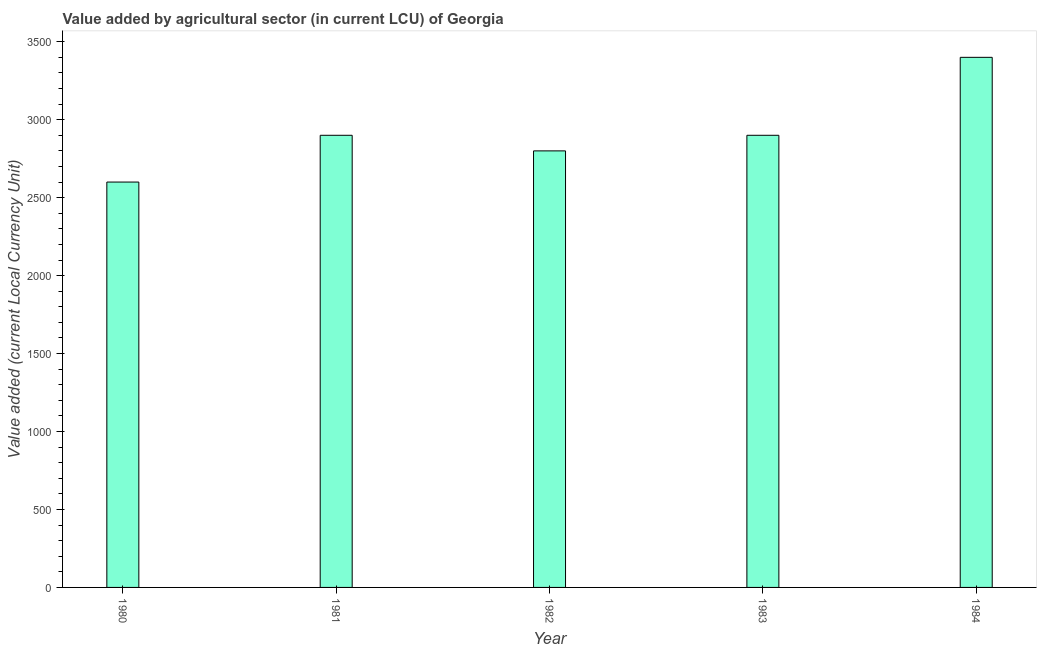What is the title of the graph?
Provide a short and direct response. Value added by agricultural sector (in current LCU) of Georgia. What is the label or title of the Y-axis?
Your answer should be compact. Value added (current Local Currency Unit). What is the value added by agriculture sector in 1981?
Keep it short and to the point. 2900. Across all years, what is the maximum value added by agriculture sector?
Your answer should be very brief. 3400. Across all years, what is the minimum value added by agriculture sector?
Your answer should be compact. 2600. What is the sum of the value added by agriculture sector?
Make the answer very short. 1.46e+04. What is the difference between the value added by agriculture sector in 1980 and 1981?
Provide a short and direct response. -300. What is the average value added by agriculture sector per year?
Your answer should be very brief. 2920. What is the median value added by agriculture sector?
Give a very brief answer. 2900. What is the ratio of the value added by agriculture sector in 1980 to that in 1981?
Offer a terse response. 0.9. Is the value added by agriculture sector in 1981 less than that in 1983?
Your response must be concise. No. Is the difference between the value added by agriculture sector in 1982 and 1983 greater than the difference between any two years?
Make the answer very short. No. What is the difference between the highest and the second highest value added by agriculture sector?
Provide a short and direct response. 500. Is the sum of the value added by agriculture sector in 1980 and 1983 greater than the maximum value added by agriculture sector across all years?
Keep it short and to the point. Yes. What is the difference between the highest and the lowest value added by agriculture sector?
Give a very brief answer. 800. In how many years, is the value added by agriculture sector greater than the average value added by agriculture sector taken over all years?
Ensure brevity in your answer.  1. How many bars are there?
Ensure brevity in your answer.  5. What is the Value added (current Local Currency Unit) in 1980?
Provide a succinct answer. 2600. What is the Value added (current Local Currency Unit) in 1981?
Provide a short and direct response. 2900. What is the Value added (current Local Currency Unit) in 1982?
Your response must be concise. 2800. What is the Value added (current Local Currency Unit) in 1983?
Your answer should be very brief. 2900. What is the Value added (current Local Currency Unit) of 1984?
Make the answer very short. 3400. What is the difference between the Value added (current Local Currency Unit) in 1980 and 1981?
Ensure brevity in your answer.  -300. What is the difference between the Value added (current Local Currency Unit) in 1980 and 1982?
Your answer should be compact. -200. What is the difference between the Value added (current Local Currency Unit) in 1980 and 1983?
Provide a short and direct response. -300. What is the difference between the Value added (current Local Currency Unit) in 1980 and 1984?
Offer a terse response. -800. What is the difference between the Value added (current Local Currency Unit) in 1981 and 1982?
Keep it short and to the point. 100. What is the difference between the Value added (current Local Currency Unit) in 1981 and 1984?
Provide a short and direct response. -500. What is the difference between the Value added (current Local Currency Unit) in 1982 and 1983?
Make the answer very short. -100. What is the difference between the Value added (current Local Currency Unit) in 1982 and 1984?
Offer a very short reply. -600. What is the difference between the Value added (current Local Currency Unit) in 1983 and 1984?
Offer a very short reply. -500. What is the ratio of the Value added (current Local Currency Unit) in 1980 to that in 1981?
Provide a succinct answer. 0.9. What is the ratio of the Value added (current Local Currency Unit) in 1980 to that in 1982?
Your response must be concise. 0.93. What is the ratio of the Value added (current Local Currency Unit) in 1980 to that in 1983?
Offer a terse response. 0.9. What is the ratio of the Value added (current Local Currency Unit) in 1980 to that in 1984?
Provide a succinct answer. 0.77. What is the ratio of the Value added (current Local Currency Unit) in 1981 to that in 1982?
Give a very brief answer. 1.04. What is the ratio of the Value added (current Local Currency Unit) in 1981 to that in 1984?
Offer a terse response. 0.85. What is the ratio of the Value added (current Local Currency Unit) in 1982 to that in 1983?
Ensure brevity in your answer.  0.97. What is the ratio of the Value added (current Local Currency Unit) in 1982 to that in 1984?
Your response must be concise. 0.82. What is the ratio of the Value added (current Local Currency Unit) in 1983 to that in 1984?
Give a very brief answer. 0.85. 